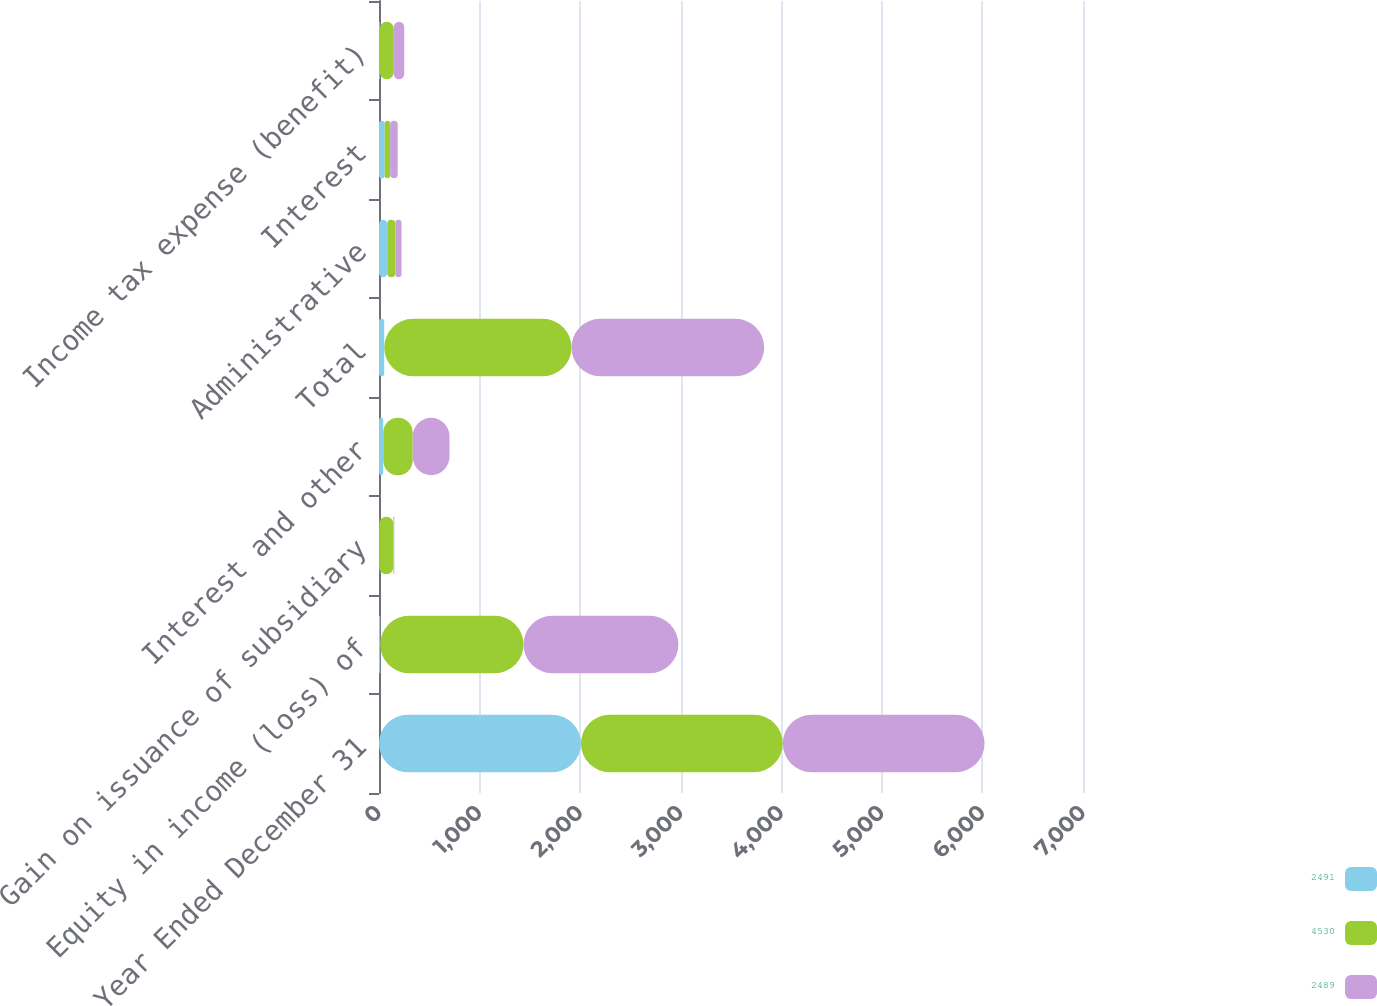Convert chart. <chart><loc_0><loc_0><loc_500><loc_500><stacked_bar_chart><ecel><fcel>Year Ended December 31<fcel>Equity in income (loss) of<fcel>Gain on issuance of subsidiary<fcel>Interest and other<fcel>Total<fcel>Administrative<fcel>Interest<fcel>Income tax expense (benefit)<nl><fcel>2491<fcel>2008<fcel>12<fcel>2<fcel>42<fcel>52<fcel>82<fcel>56<fcel>8<nl><fcel>4530<fcel>2007<fcel>1425<fcel>141<fcel>293<fcel>1862<fcel>81<fcel>55<fcel>139<nl><fcel>2489<fcel>2006<fcel>1540<fcel>9<fcel>366<fcel>1916<fcel>61<fcel>75<fcel>104<nl></chart> 